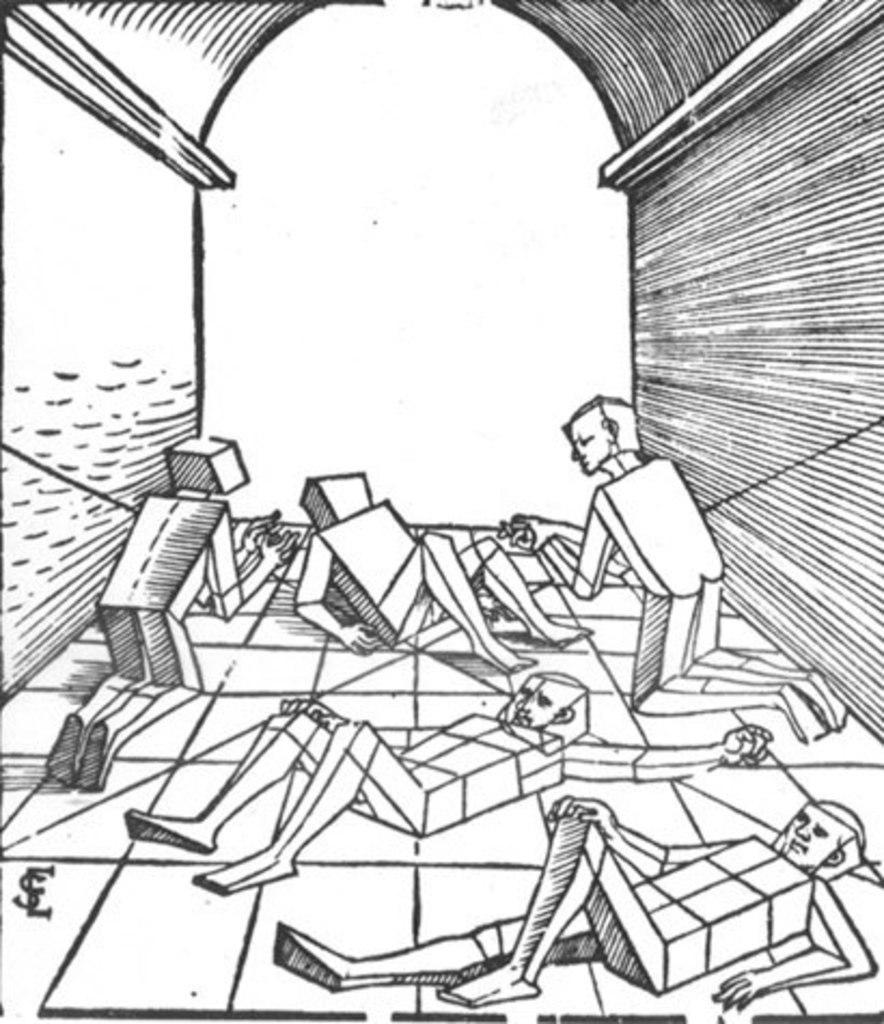Could you give a brief overview of what you see in this image? In this image, we can see a sketch. Here we can see few people and wall. Few people are lying on the floor. 